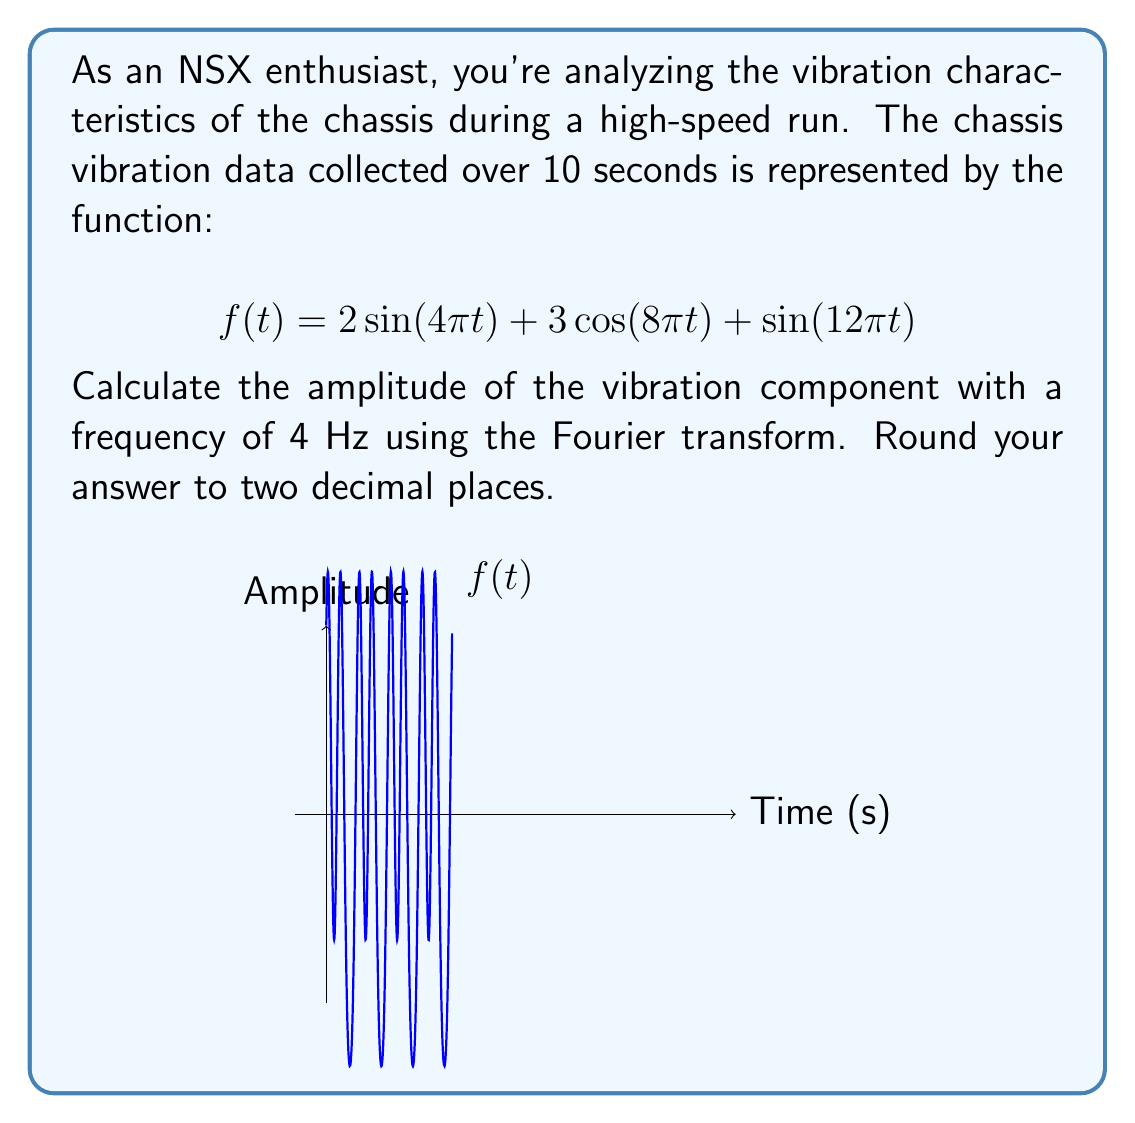Teach me how to tackle this problem. To solve this problem, we'll follow these steps:

1) The Fourier transform $F(\omega)$ of a function $f(t)$ is given by:

   $$F(\omega) = \int_{-\infty}^{\infty} f(t) e^{-i\omega t} dt$$

2) For our function $f(t) = 2\sin(4\pi t) + 3\cos(8\pi t) + \sin(12\pi t)$, we need to identify the component with frequency 4 Hz.

3) In the given function, $2\sin(4\pi t)$ represents the 4 Hz component. This is because:
   
   $\omega = 2\pi f$, where $f$ is frequency in Hz
   $4\pi = 2\pi(2)$, so $f = 2$ Hz

4) The amplitude of this component is 2.

5) However, in the Fourier transform, the amplitude is split between positive and negative frequencies. For a real-valued sine function, the amplitude in the frequency domain is half of the time-domain amplitude.

6) Therefore, the amplitude in the frequency domain for the 4 Hz component is 2/2 = 1.

7) Rounding to two decimal places gives 1.00.
Answer: 1.00 